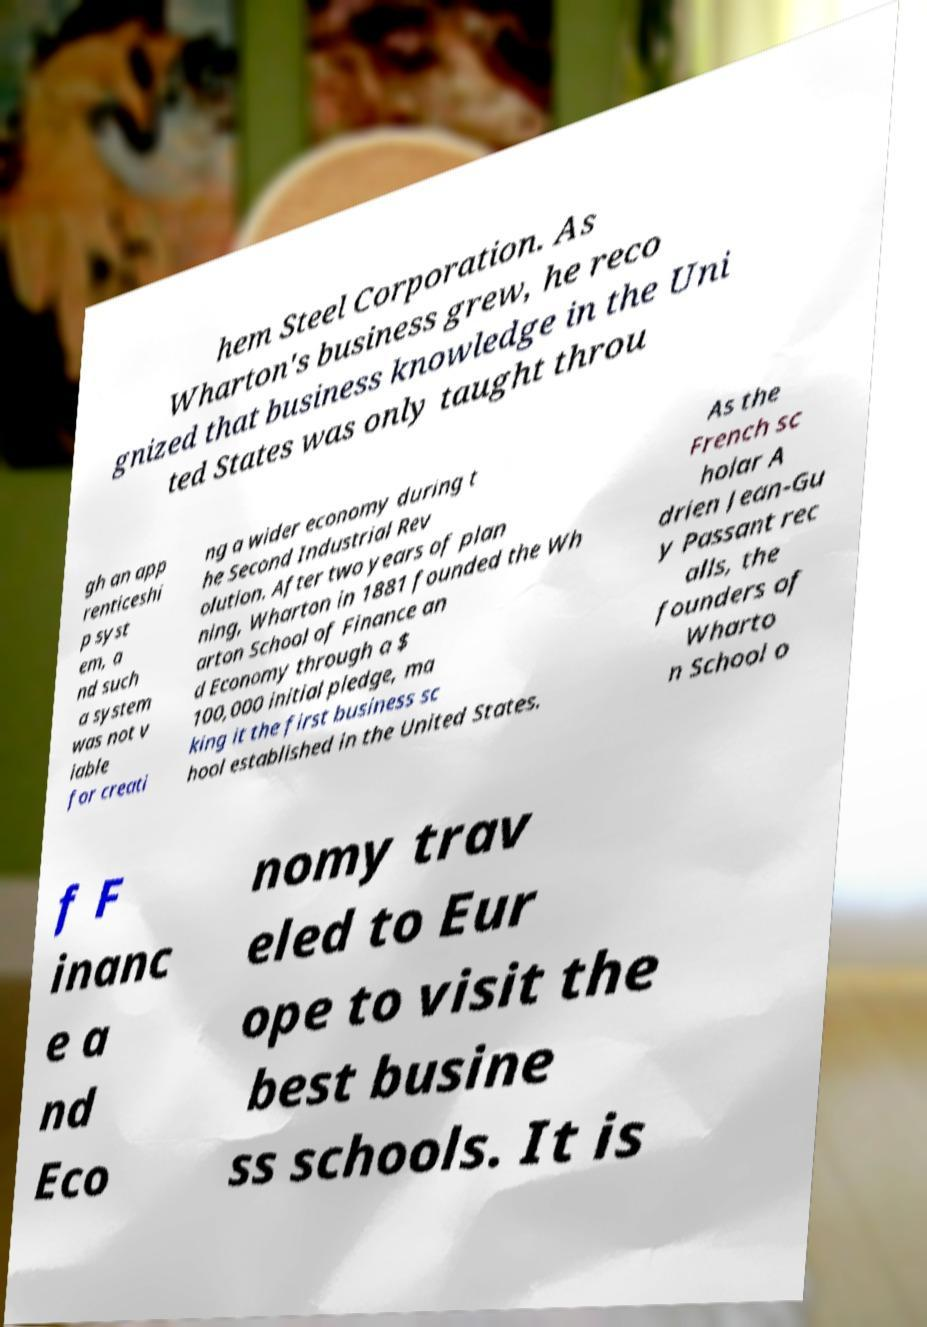There's text embedded in this image that I need extracted. Can you transcribe it verbatim? hem Steel Corporation. As Wharton's business grew, he reco gnized that business knowledge in the Uni ted States was only taught throu gh an app renticeshi p syst em, a nd such a system was not v iable for creati ng a wider economy during t he Second Industrial Rev olution. After two years of plan ning, Wharton in 1881 founded the Wh arton School of Finance an d Economy through a $ 100,000 initial pledge, ma king it the first business sc hool established in the United States. As the French sc holar A drien Jean-Gu y Passant rec alls, the founders of Wharto n School o f F inanc e a nd Eco nomy trav eled to Eur ope to visit the best busine ss schools. It is 